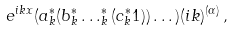<formula> <loc_0><loc_0><loc_500><loc_500>e ^ { i k x } ( a ^ { * } _ { k } ( b ^ { * } _ { k } \dots ^ { * } _ { k } ( c ^ { * } _ { k } 1 ) ) \dots ) ( i k ) ^ { ( \alpha ) } \, ,</formula> 